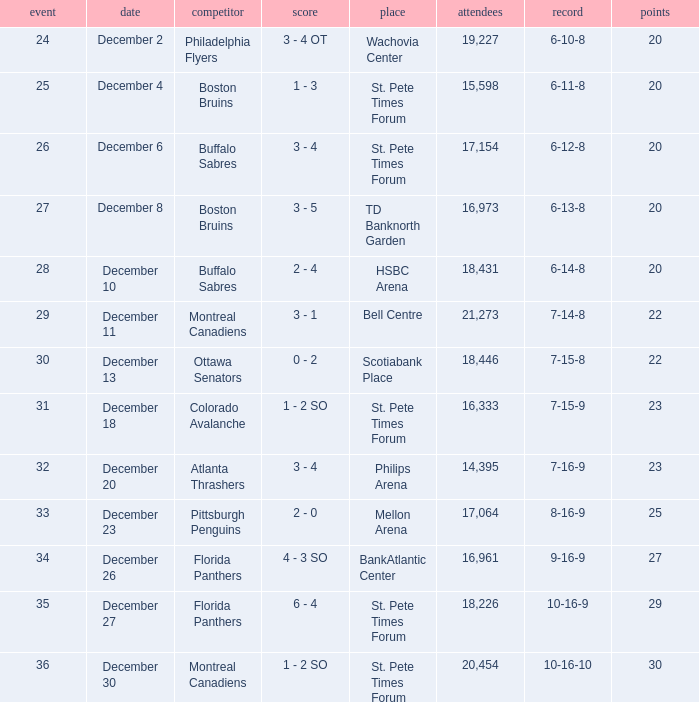What is the location of the game with a 6-11-8 record? St. Pete Times Forum. 